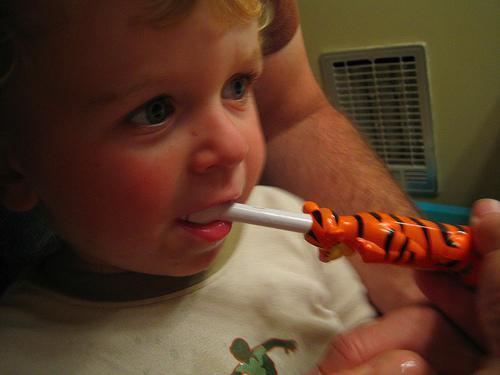How many children are photographed?
Give a very brief answer. 1. 